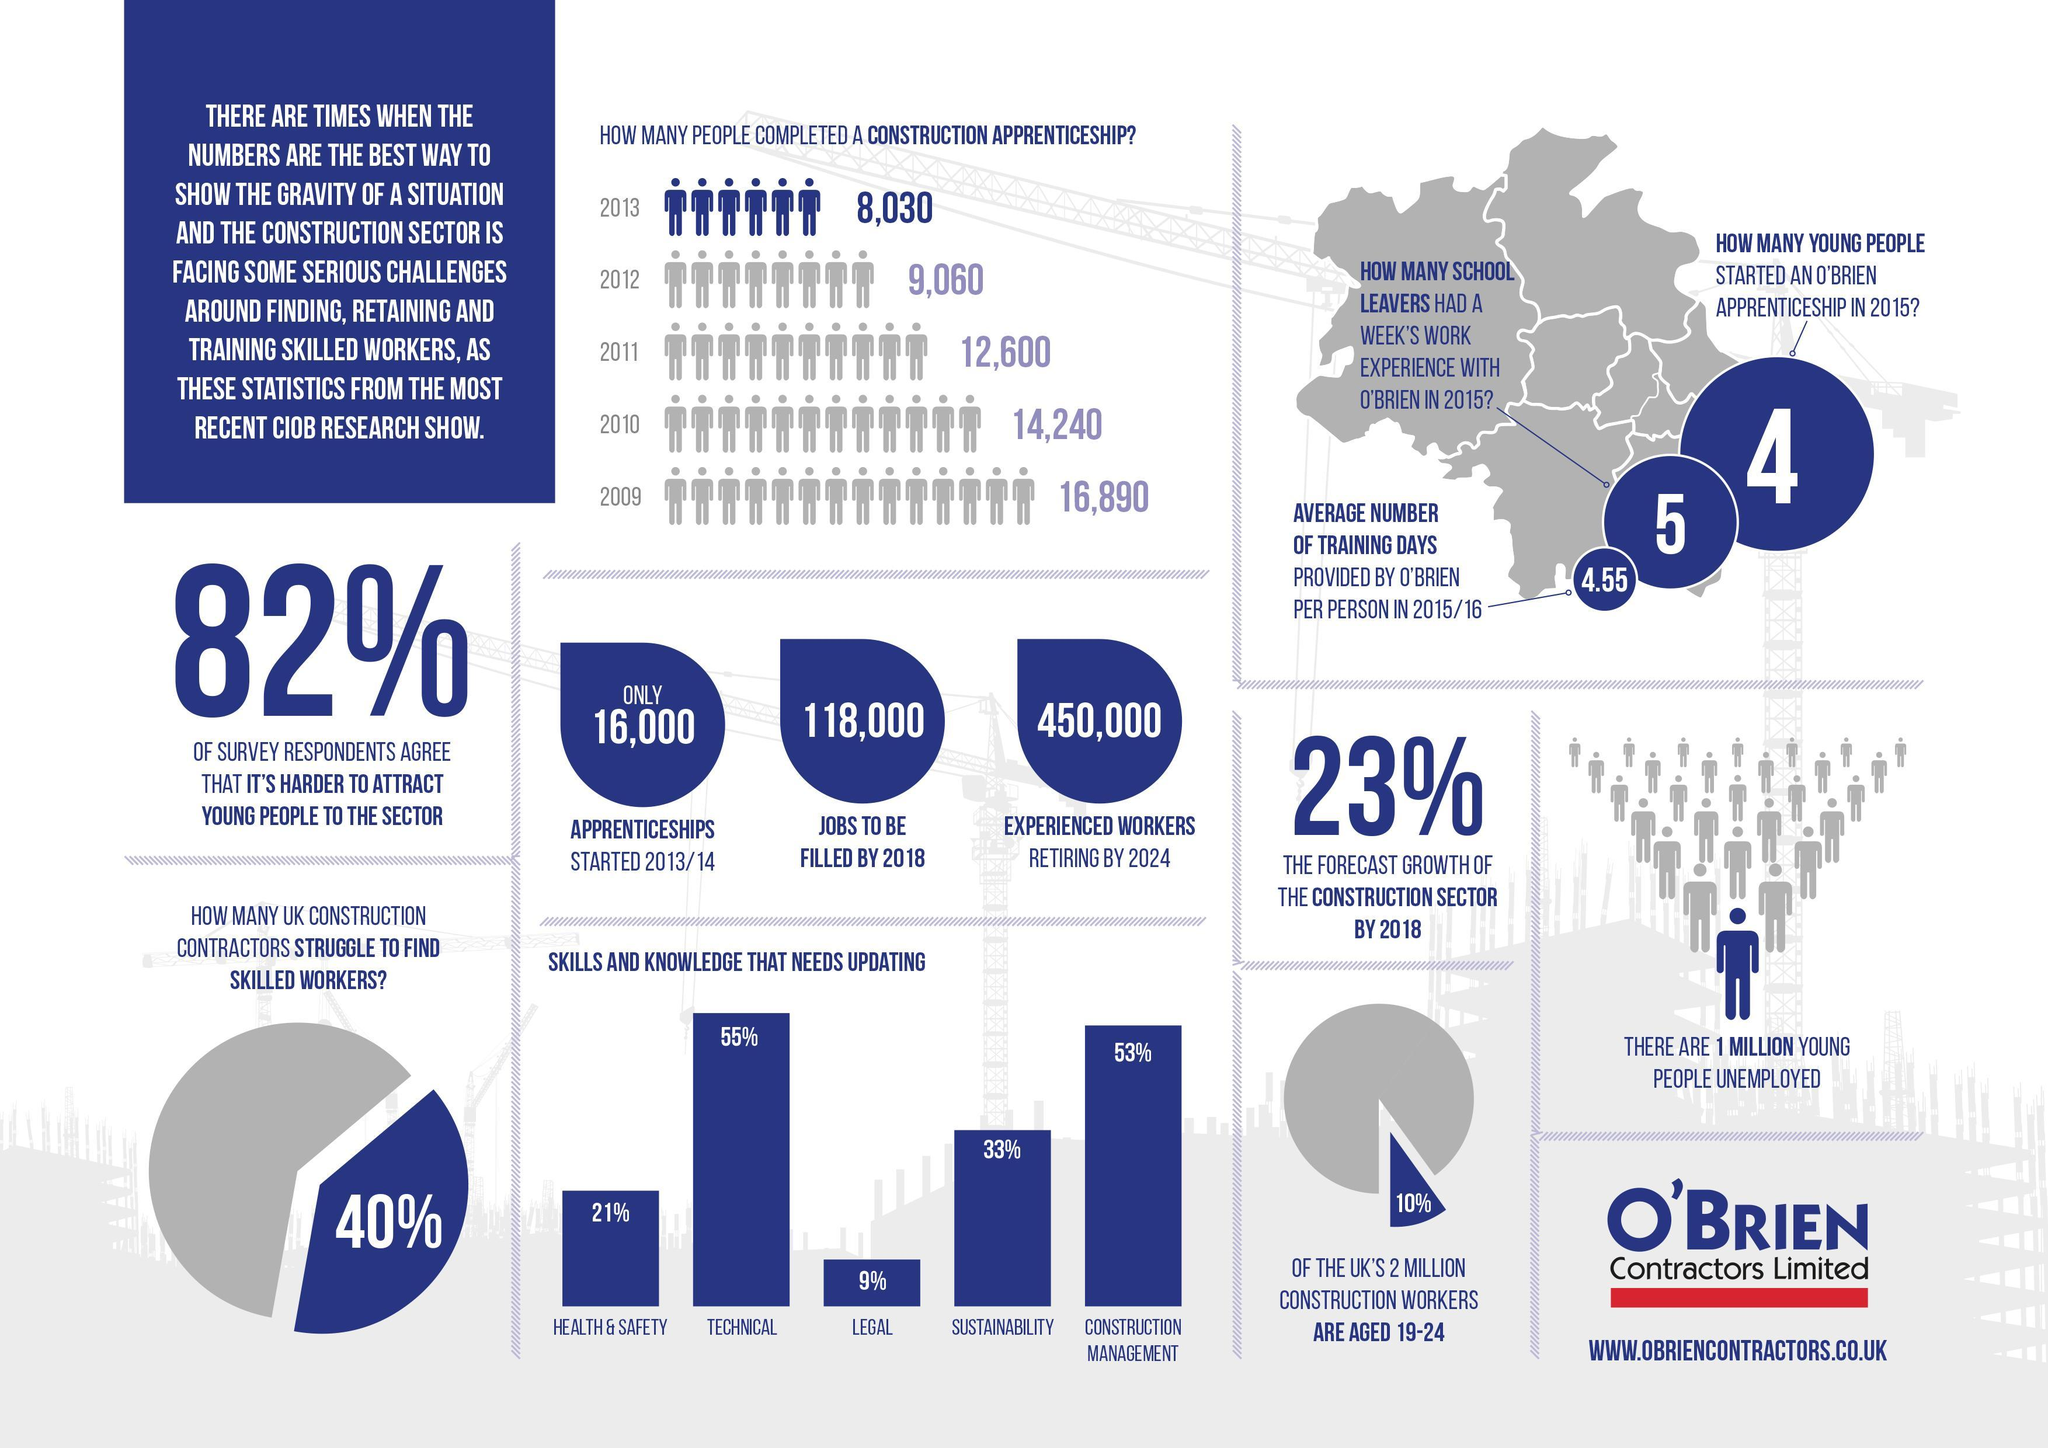what is the estimated number of experienced workers retiring in 2024?
Answer the question with a short phrase. 450,000 What skills and knowledge that needs updating comes second? construction management What are the skills and knowledge that needs updating the most? technical How much decrease did the number of people who completed a construction apprenticeship see from 2009 to 2013? 8,860 